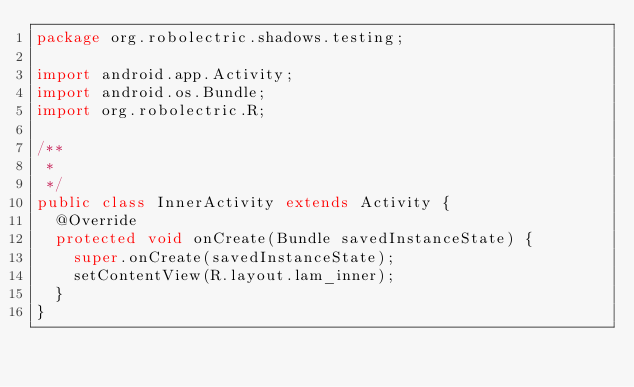<code> <loc_0><loc_0><loc_500><loc_500><_Java_>package org.robolectric.shadows.testing;

import android.app.Activity;
import android.os.Bundle;
import org.robolectric.R;

/**
 *
 */
public class InnerActivity extends Activity {
  @Override
  protected void onCreate(Bundle savedInstanceState) {
    super.onCreate(savedInstanceState);
    setContentView(R.layout.lam_inner);
  }
}
</code> 